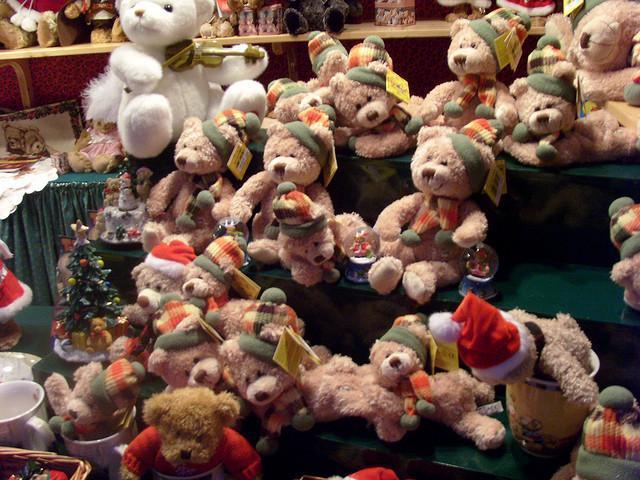How many cups are there?
Give a very brief answer. 3. How many teddy bears are there?
Give a very brief answer. 14. 